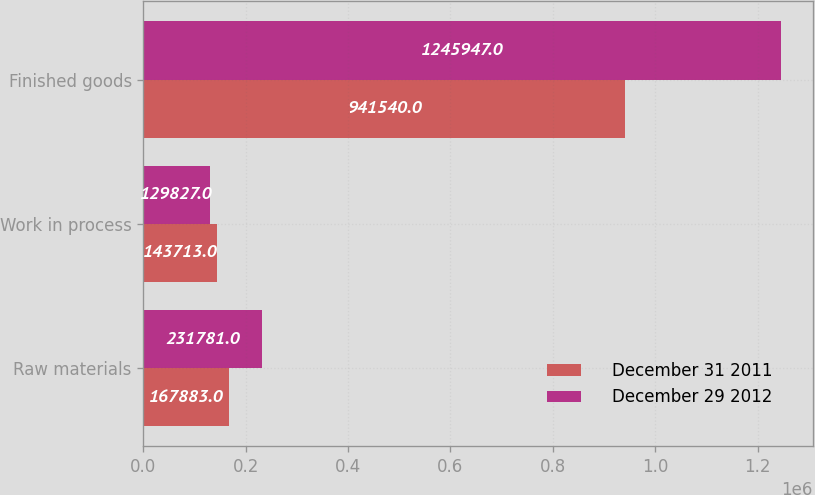Convert chart. <chart><loc_0><loc_0><loc_500><loc_500><stacked_bar_chart><ecel><fcel>Raw materials<fcel>Work in process<fcel>Finished goods<nl><fcel>December 31 2011<fcel>167883<fcel>143713<fcel>941540<nl><fcel>December 29 2012<fcel>231781<fcel>129827<fcel>1.24595e+06<nl></chart> 